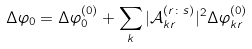<formula> <loc_0><loc_0><loc_500><loc_500>\Delta \varphi _ { 0 } = \Delta \varphi _ { 0 } ^ { ( 0 ) } + \sum _ { k } | \mathcal { A } _ { k r } ^ { ( r \colon s ) } | ^ { 2 } \Delta \varphi _ { k r } ^ { ( 0 ) }</formula> 